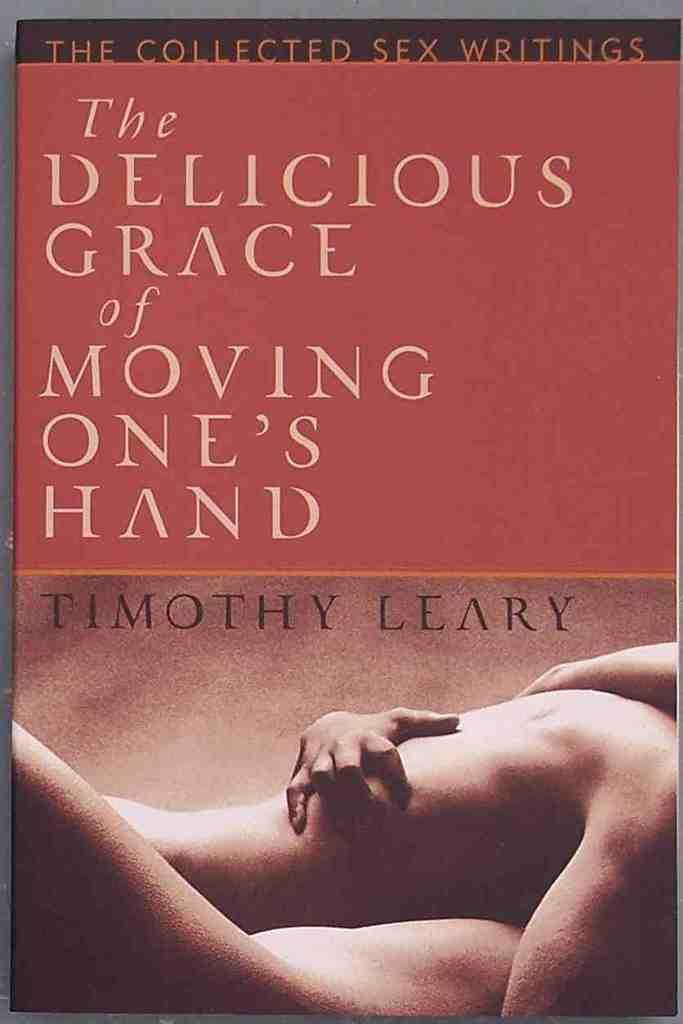<image>
Offer a succinct explanation of the picture presented. A book about romance made by Timothy Leary 